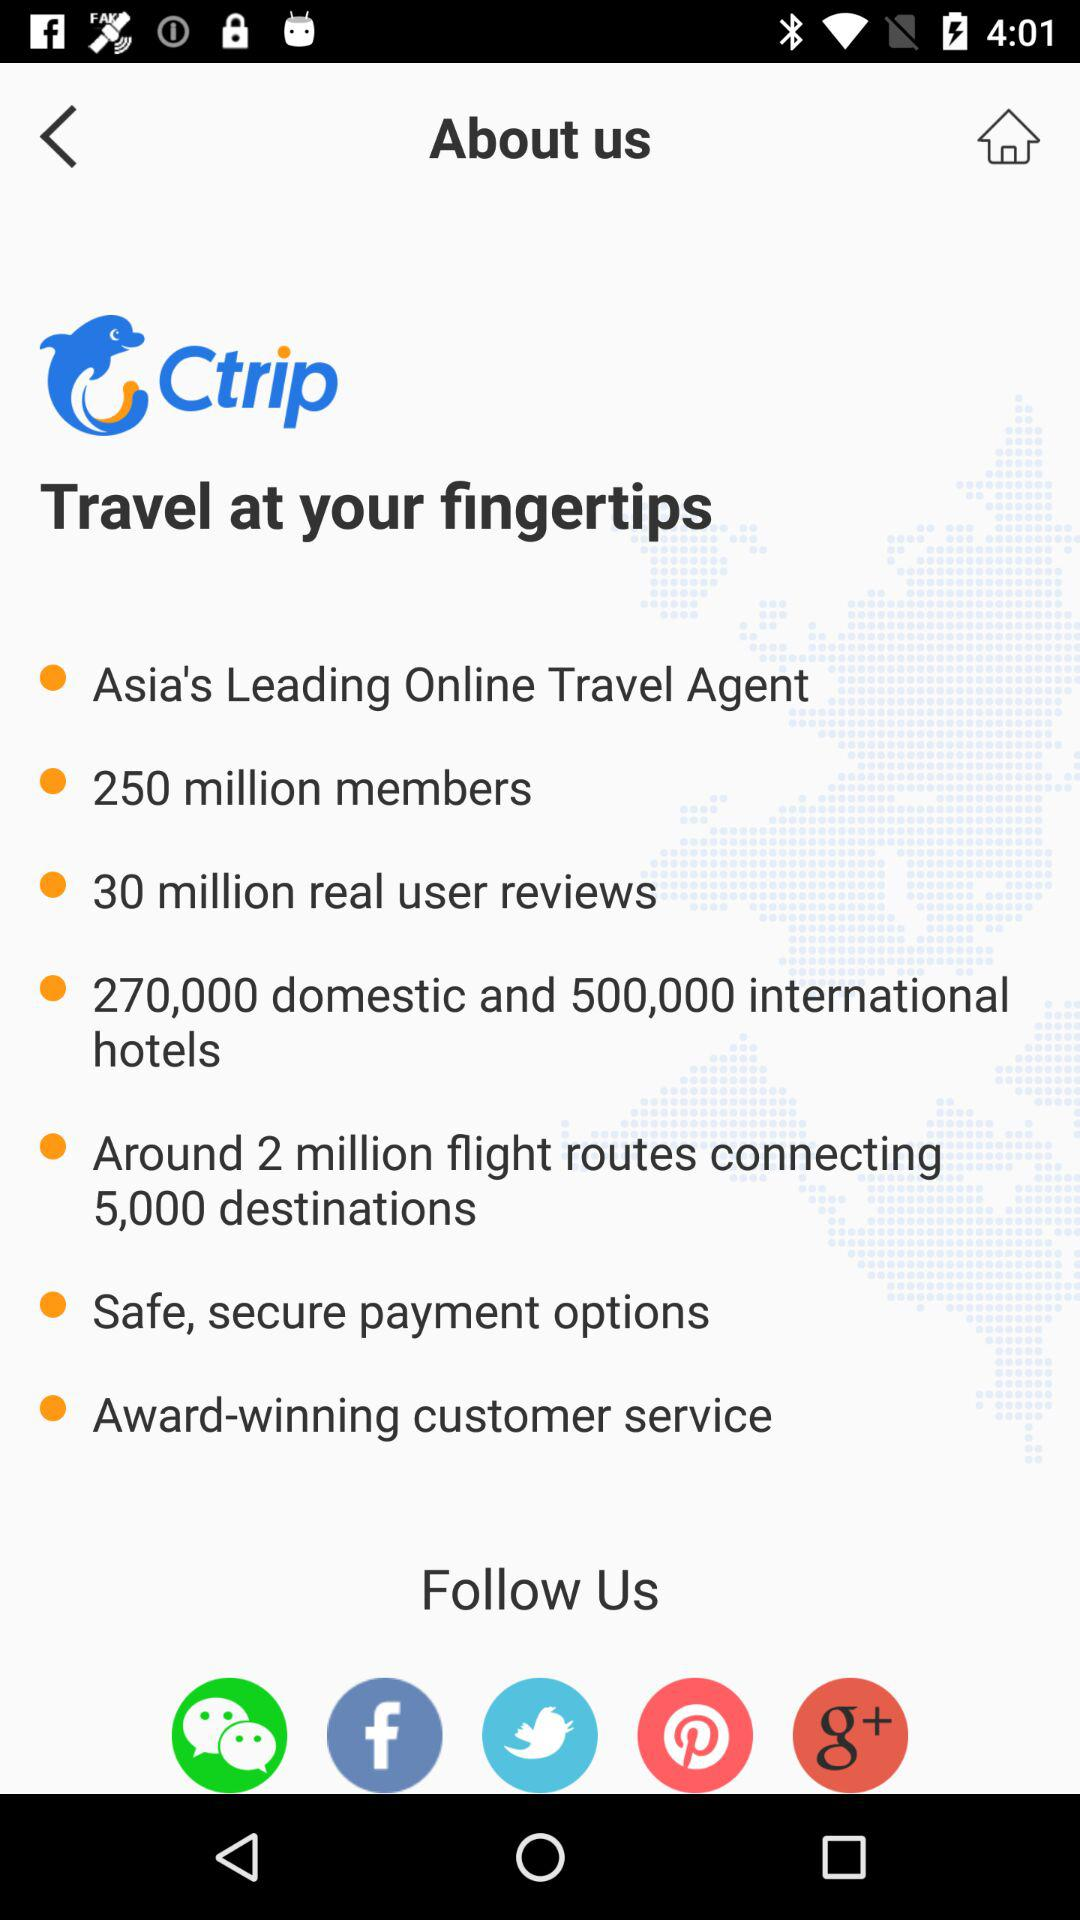Through what applications can we follow? The applications are "WeChat", "Facebook", "Twitter", "Pinterest", and "Google+". 